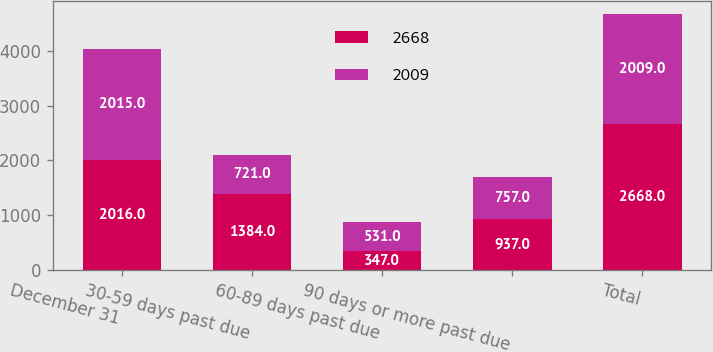Convert chart to OTSL. <chart><loc_0><loc_0><loc_500><loc_500><stacked_bar_chart><ecel><fcel>December 31<fcel>30-59 days past due<fcel>60-89 days past due<fcel>90 days or more past due<fcel>Total<nl><fcel>2668<fcel>2016<fcel>1384<fcel>347<fcel>937<fcel>2668<nl><fcel>2009<fcel>2015<fcel>721<fcel>531<fcel>757<fcel>2009<nl></chart> 